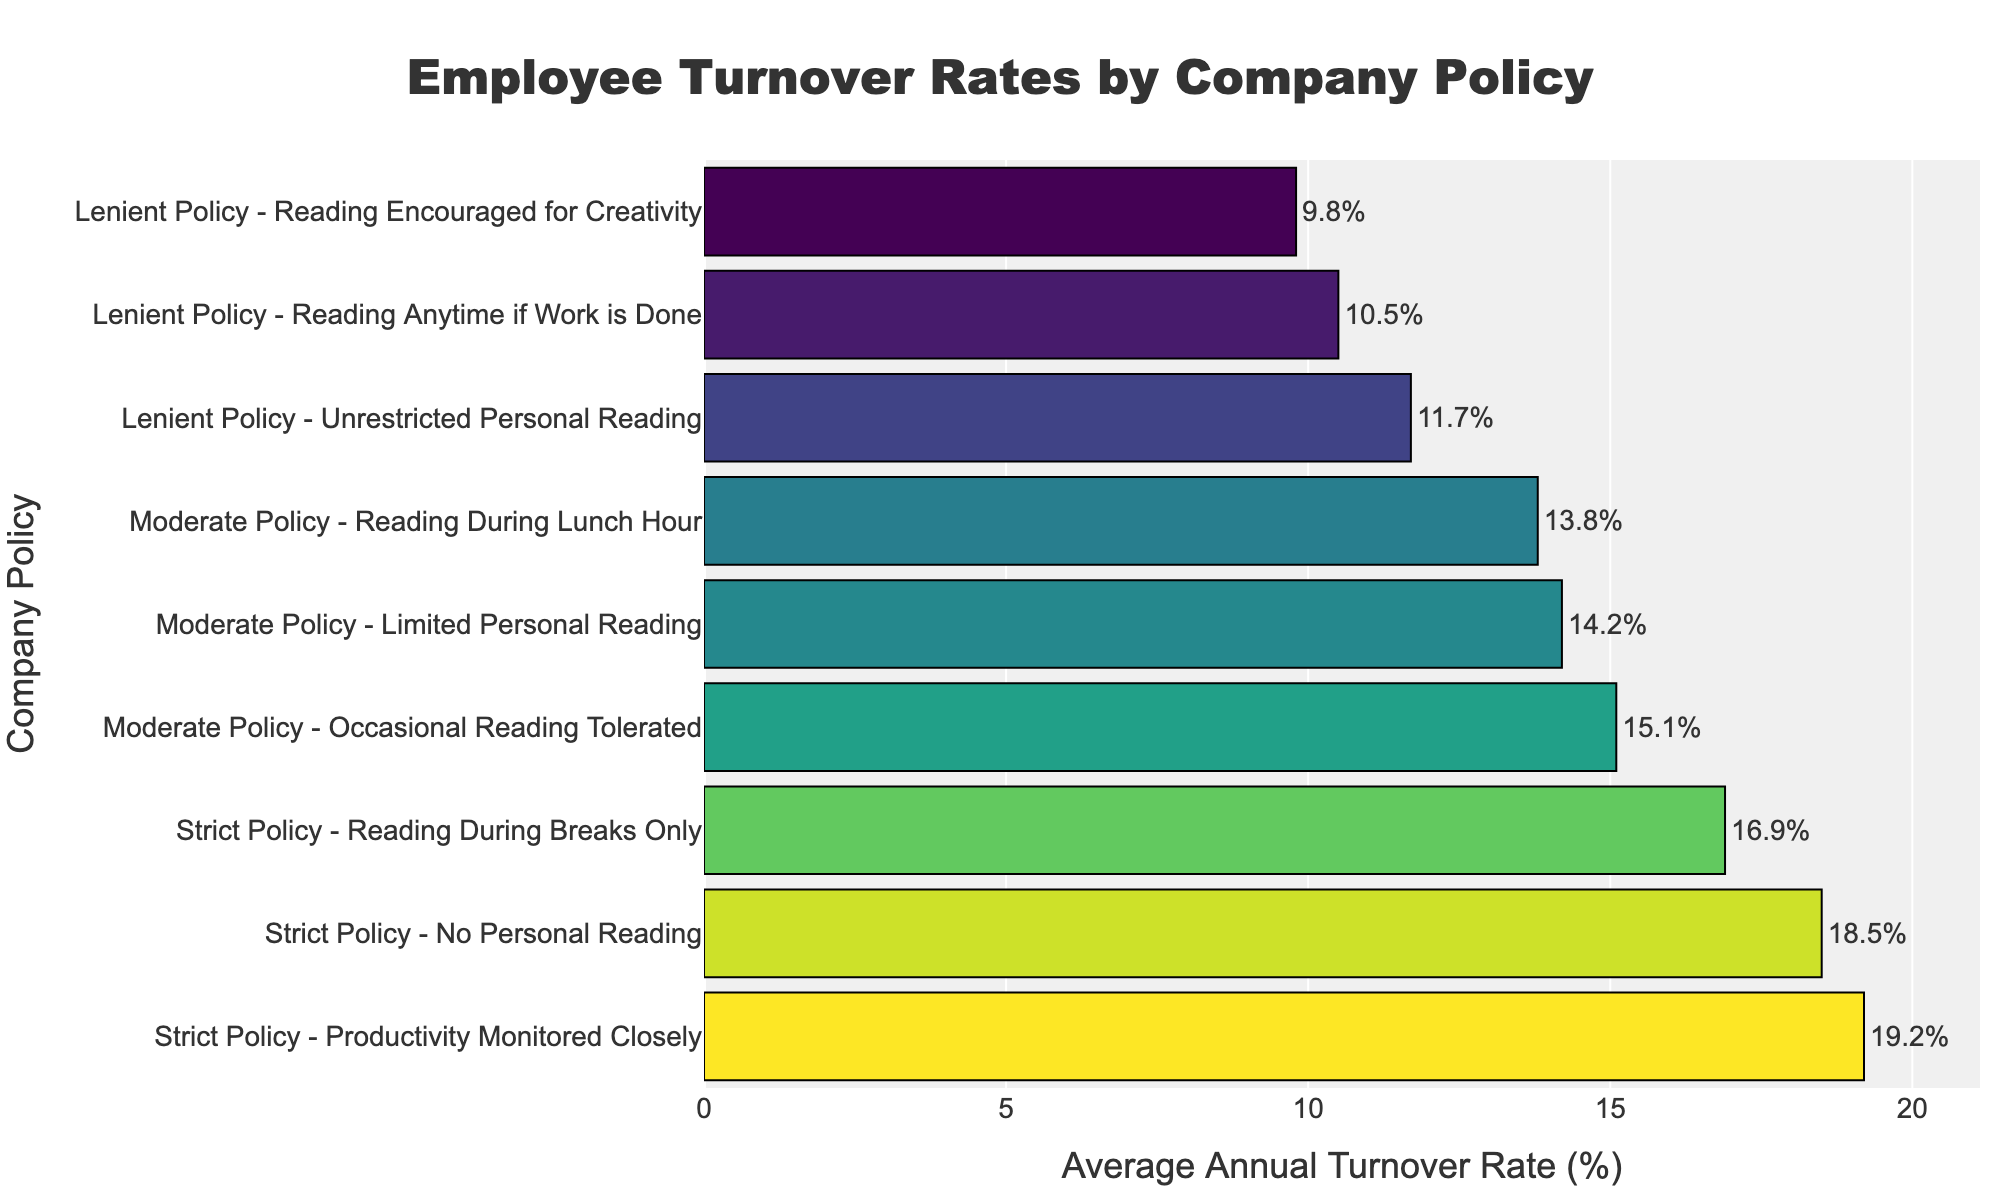What is the average turnover rate for companies with lenient policies? Calculate the average by summing the turnover rates for all lenient policies and dividing by the number of lenient policies: (11.7 + 10.5 + 9.8) / 3 = 10.67%
Answer: 10.67% Which company type has the highest turnover rate? Identify the company type with the highest bar length in the plot, which corresponds to "Strict Policy - Productivity Monitored Closely" at 19.2%.
Answer: Strict Policy - Productivity Monitored Closely Between "Strict Policy - No Personal Reading" and "Lenient Policy - Unrestricted Personal Reading," which has a lower turnover rate? Compare the turnover rates of the two specified policies: 11.7% (Lenient Policy) < 18.5% (Strict Policy).
Answer: Lenient Policy - Unrestricted Personal Reading What is the difference in turnover rate between the strictest and most lenient company policies? Find the highest turnover rate among strict policies (19.2%) and the lowest among lenient policies (9.8%), then subtract the latter from the former: 19.2% - 9.8% = 9.4%.
Answer: 9.4% List company policies in order from highest to lowest turnover rate. Arrange the policies based on the descending order of turnover rates: 
1. Strict Policy - Productivity Monitored Closely (19.2%)
2. Strict Policy - No Personal Reading (18.5%)
3. Strict Policy - Reading During Breaks Only (16.9%)
4. Moderate Policy - Occasional Reading Tolerated (15.1%)
5. Moderate Policy - Limited Personal Reading (14.2%)
6. Moderate Policy - Reading During Lunch Hour (13.8%)
7. Lenient Policy - Unrestricted Personal Reading (11.7%)
8. Lenient Policy - Reading Anytime if Work is Done (10.5%)
9. Lenient Policy - Reading Encouraged for Creativity (9.8%).
Answer: List provided in the explanation What is the combined turnover rate for all strict policies? Sum the turnover rates of all strict policies: 18.5 + 16.9 + 19.2 = 54.6%.
Answer: 54.6% How much higher is the turnover rate for "Moderate Policy - Occasional Reading Tolerated" compared to "Moderate Policy - Reading During Lunch Hour"? Subtract the lower rate (13.8%) from the higher rate (15.1%): 15.1% - 13.8% = 1.3%.
Answer: 1.3% What is the color indicating higher turnover rates in the chart? The color scale in the bar chart used, typically in 'Viridis,' with darker shades indicating higher turnover rates.
Answer: Darker shades Which lenient policy shows the lowest turnover rate? Identify the lenient policy with the shortest bar: "Lenient Policy - Reading Encouraged for Creativity" has the lowest turnover rate at 9.8%.
Answer: Lenient Policy - Reading Encouraged for Creativity 